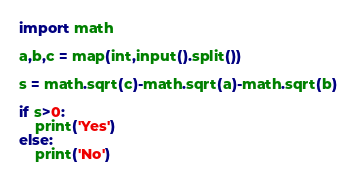<code> <loc_0><loc_0><loc_500><loc_500><_Python_>import math

a,b,c = map(int,input().split())

s = math.sqrt(c)-math.sqrt(a)-math.sqrt(b)

if s>0:
    print('Yes')
else:
    print('No')
</code> 